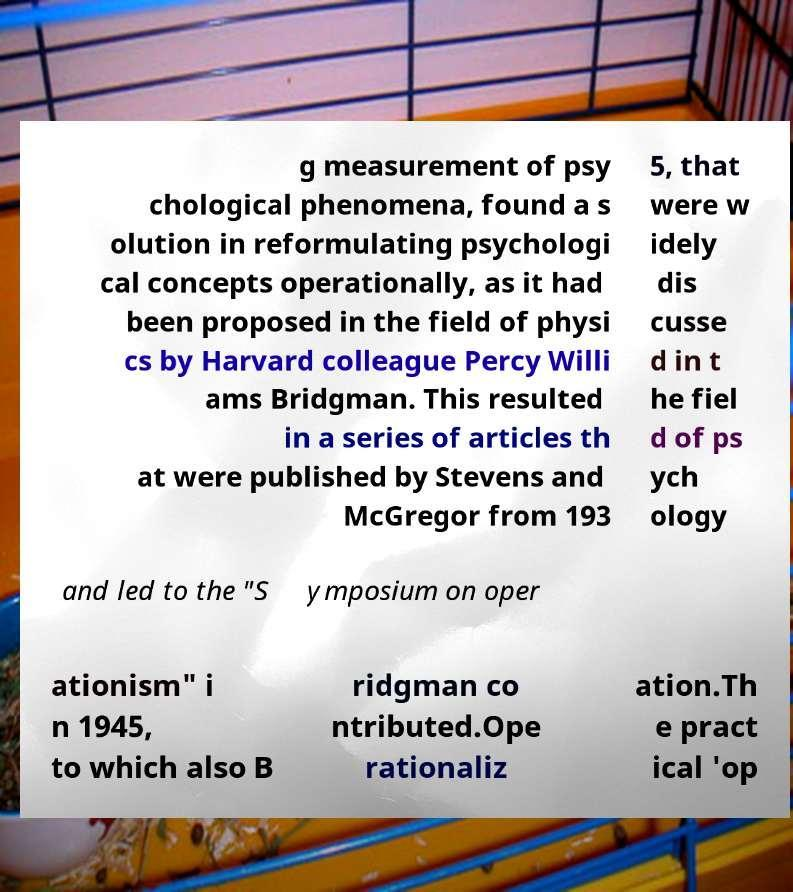Please identify and transcribe the text found in this image. g measurement of psy chological phenomena, found a s olution in reformulating psychologi cal concepts operationally, as it had been proposed in the field of physi cs by Harvard colleague Percy Willi ams Bridgman. This resulted in a series of articles th at were published by Stevens and McGregor from 193 5, that were w idely dis cusse d in t he fiel d of ps ych ology and led to the "S ymposium on oper ationism" i n 1945, to which also B ridgman co ntributed.Ope rationaliz ation.Th e pract ical 'op 